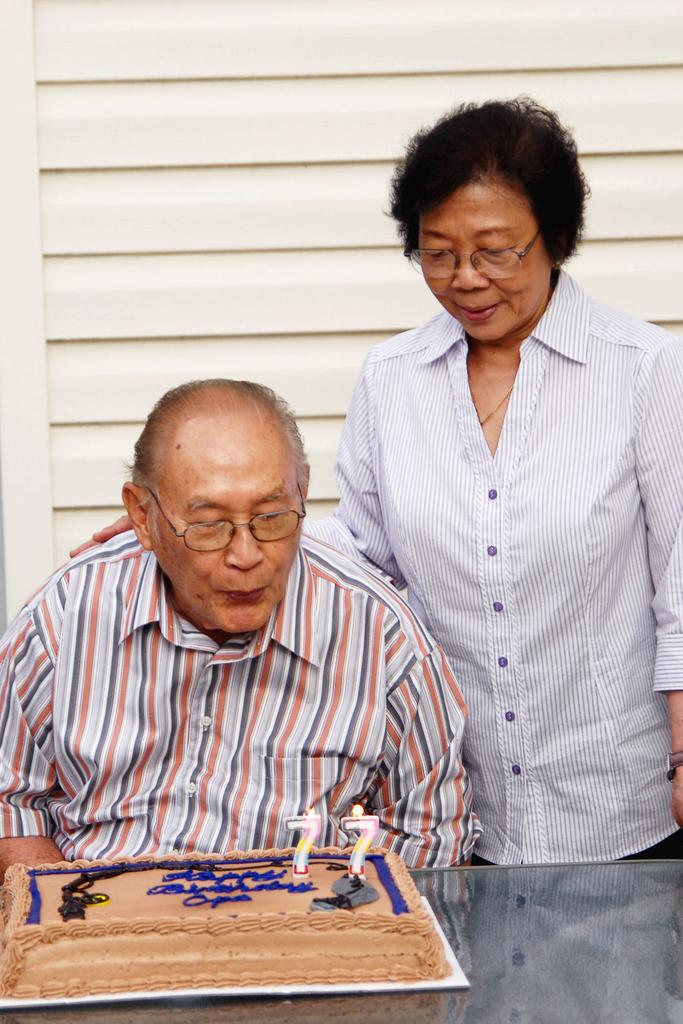What is the person sitting in the chair doing? The person is blowing candles. Where are the candles located? The candles are on a cake. What is the position of the cake in relation to the person sitting in the chair? The cake is in front of the person sitting in the chair. Is there anyone else present in the image? Yes, there is another person standing beside the person sitting in the chair. What type of needle is being used to sew the pest in the image? There is no needle or pest present in the image; it features a person sitting in a chair blowing candles on a cake. 